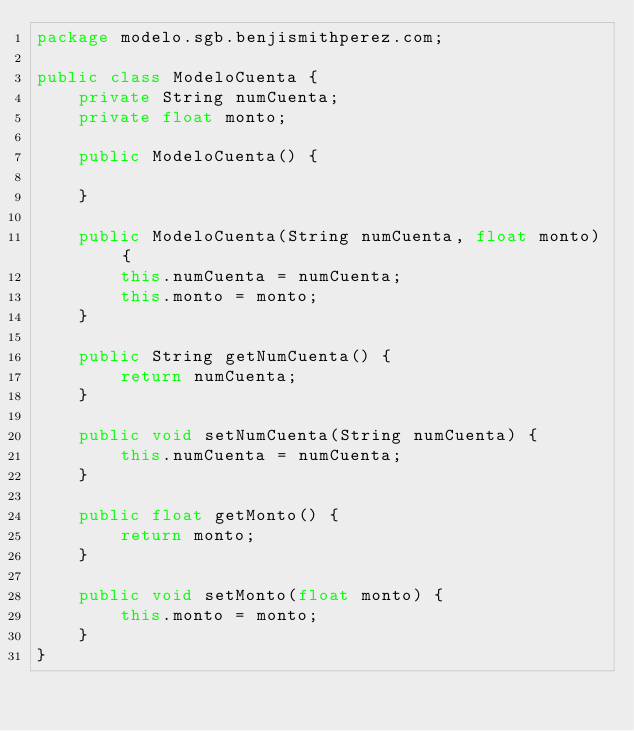<code> <loc_0><loc_0><loc_500><loc_500><_Java_>package modelo.sgb.benjismithperez.com;

public class ModeloCuenta {
	private String numCuenta;
	private float monto;
	
	public ModeloCuenta() {
		
	}
	
	public ModeloCuenta(String numCuenta, float monto) {
		this.numCuenta = numCuenta;
		this.monto = monto;
	}

	public String getNumCuenta() {
		return numCuenta;
	}
	
	public void setNumCuenta(String numCuenta) {
		this.numCuenta = numCuenta;
	}
	
	public float getMonto() {
		return monto;
	}
	
	public void setMonto(float monto) {
		this.monto = monto;
	}
}
</code> 